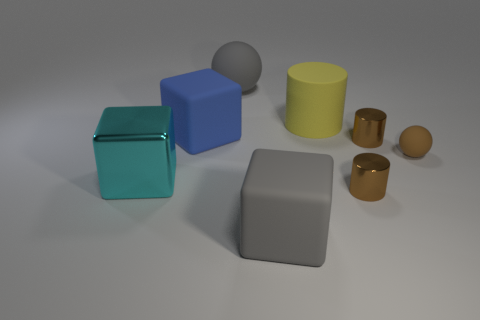Are there an equal number of cyan cubes behind the big cyan cube and big cyan cubes?
Make the answer very short. No. Do the large gray object behind the blue cube and the cyan cube have the same material?
Offer a terse response. No. Are there fewer objects that are right of the big yellow rubber object than tiny gray spheres?
Your answer should be very brief. No. How many rubber things are brown cylinders or large cyan blocks?
Make the answer very short. 0. Is the color of the large cylinder the same as the large shiny block?
Offer a terse response. No. Is there any other thing that is the same color as the matte cylinder?
Provide a short and direct response. No. There is a large rubber thing that is behind the yellow object; does it have the same shape as the big object that is left of the large blue block?
Offer a terse response. No. What number of things are big purple balls or tiny brown objects that are behind the brown sphere?
Offer a very short reply. 1. How many other things are the same size as the gray matte block?
Give a very brief answer. 4. Does the sphere that is behind the brown matte thing have the same material as the large gray thing in front of the cyan metal object?
Your answer should be very brief. Yes. 